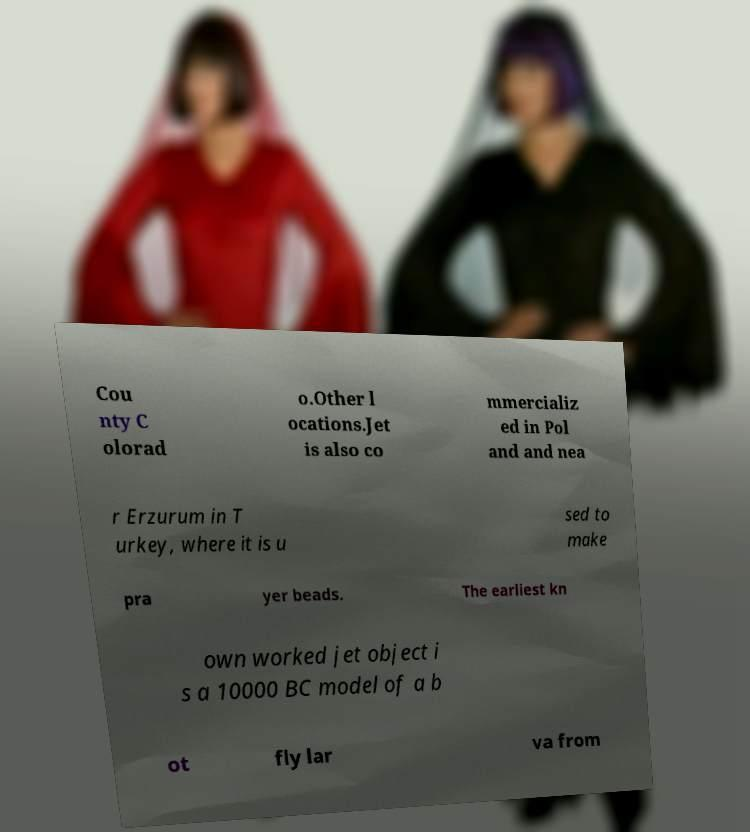Could you extract and type out the text from this image? Cou nty C olorad o.Other l ocations.Jet is also co mmercializ ed in Pol and and nea r Erzurum in T urkey, where it is u sed to make pra yer beads. The earliest kn own worked jet object i s a 10000 BC model of a b ot fly lar va from 